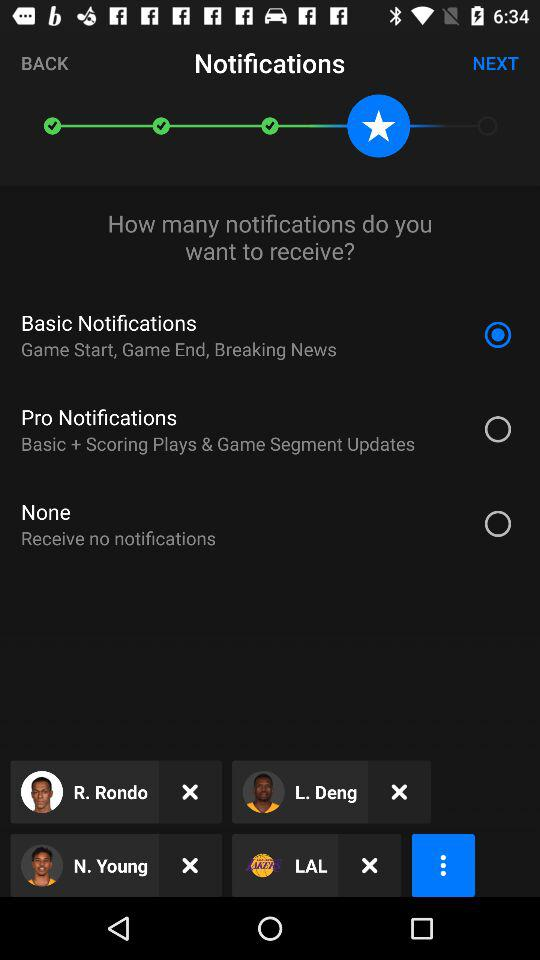How many more notifications does the Pro notifications option offer than the Basic notifications option?
Answer the question using a single word or phrase. 2 